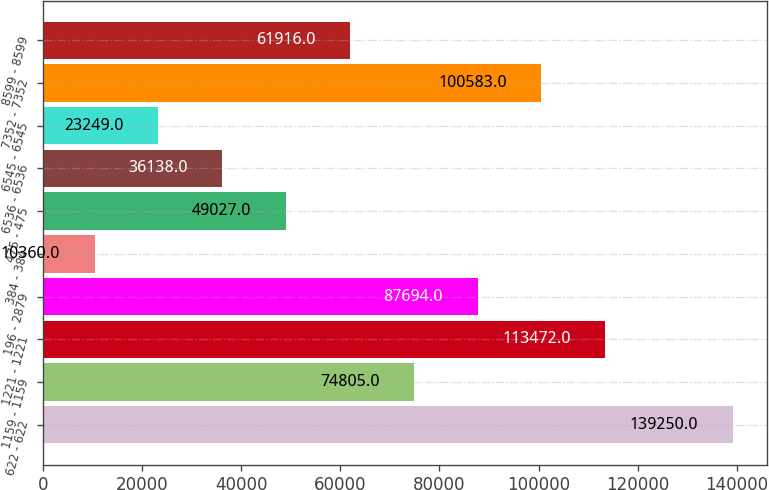<chart> <loc_0><loc_0><loc_500><loc_500><bar_chart><fcel>622 - 622<fcel>1159 - 1159<fcel>1221 - 1221<fcel>196 - 2879<fcel>384 - 384<fcel>475 - 475<fcel>6536 - 6536<fcel>6545 - 6545<fcel>7352 - 7352<fcel>8599 - 8599<nl><fcel>139250<fcel>74805<fcel>113472<fcel>87694<fcel>10360<fcel>49027<fcel>36138<fcel>23249<fcel>100583<fcel>61916<nl></chart> 